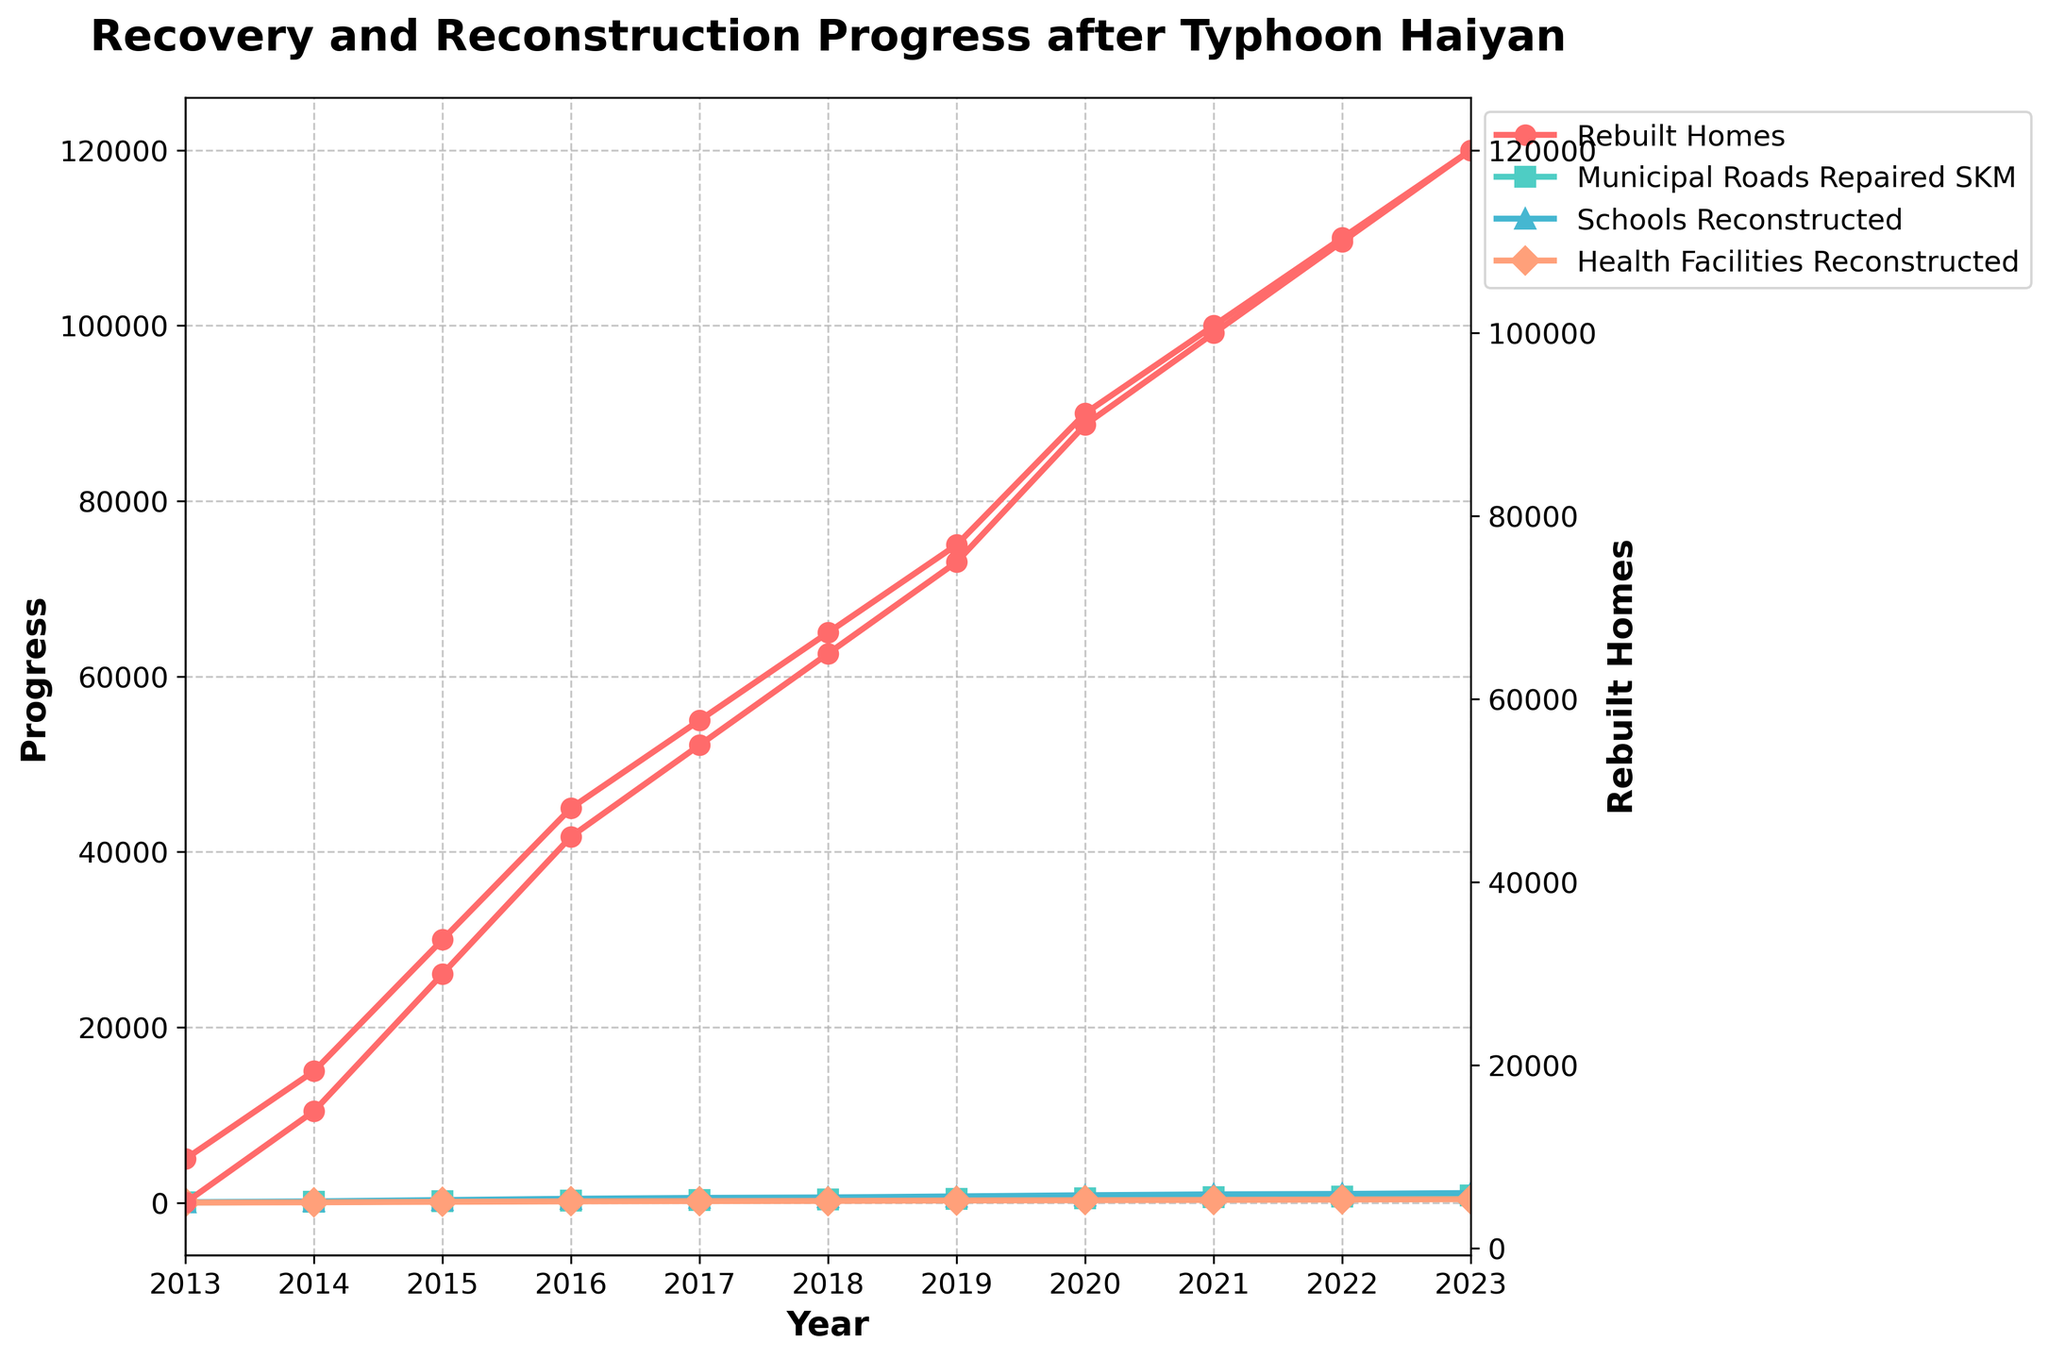How many health facilities were reconstructed in 2021? The plot shows the number of reconstructed health facilities each year. By referring to the plot for the year 2021, we can see that 315 health facilities were reconstructed.
Answer: 315 How many more homes were rebuilt in 2023 compared to 2013? The plot shows the number of rebuilt homes over the years. In 2023, 120,000 homes were rebuilt, while in 2013, only 5,000 homes were rebuilt. The difference is 120,000 - 5,000 = 115,000 homes.
Answer: 115,000 What is the trend in the number of municipal roads repaired from 2013 to 2023? Observing the line corresponding to municipal roads repaired, we see a consistent upward trend from 2013 (30 SKM) to 2023 (800 SKM).
Answer: Upward trend Which year saw the highest number of schools reconstructed? By looking at the line representing schools reconstructed, the highest value is observed in 2023, where 1,100 schools were reconstructed.
Answer: 2023 How did the number of rebuilt homes progress between 2019 and 2021? In 2019, 75,000 homes were rebuilt, progressing to 90,000 in 2020, and further to 100,000 in 2021. This shows a steady increase in the number of rebuilt homes over these years.
Answer: Steady increase By how much did the number of schools reconstructed increase from 2018 to 2019? According to the plot, the number of schools reconstructed in 2018 is 600, and it rises to 720 in 2019. The increase is 720 - 600 = 120 schools.
Answer: 120 Compare the number of schools reconstructed and health facilities reconstructed in 2015. Which is higher and by how much? In 2015, there were 300 schools reconstructed and 100 health facilities reconstructed. The difference is 300 - 100 = 200, with schools being higher.
Answer: Schools by 200 What was the approximate time period when the number of rebuilt homes reached halfway (60,000)? The plot shows the increase in rebuilt homes, reaching halfway at around 2018 when the number of rebuilt homes crosses 60,000.
Answer: Around 2018 Which infrastructure category had the slowest growth between 2013 and 2023? By comparing the growth trends lines for each category, health facilities reconstructed show a slower growth compared to rebuilt homes, municipal roads repaired, and schools reconstructed.
Answer: Health facilities reconstructed 